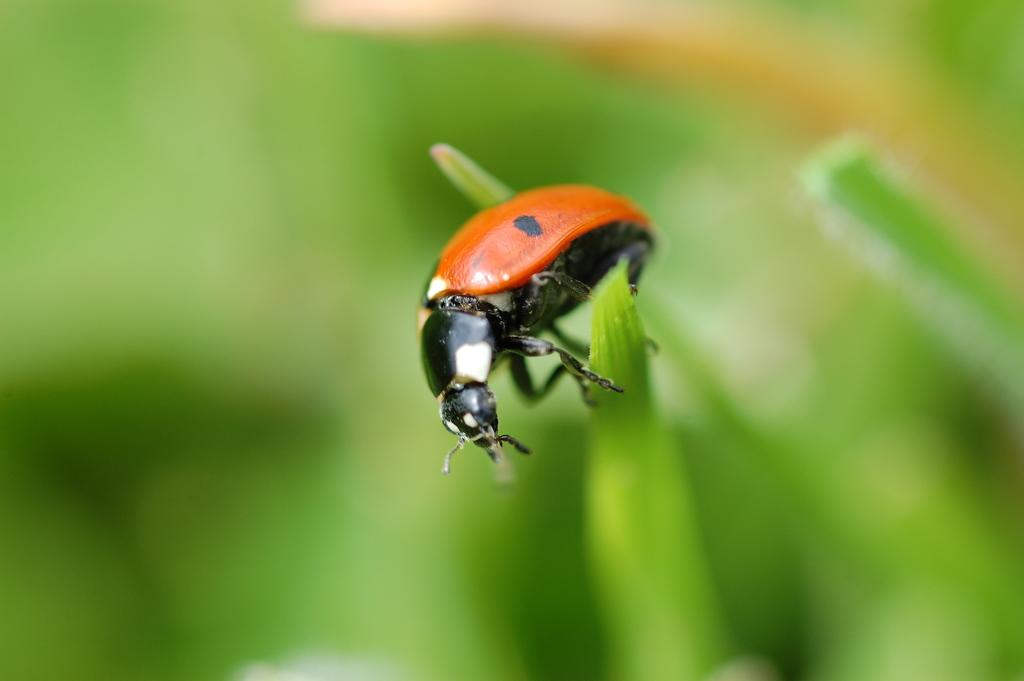What is present in the image? There is a bug in the image. Where is the bug located? The bug is on a leaf. Can you describe the position of the bug and leaf in the image? The bug and leaf are in the center of the image. What type of sheet is covering the bug in the image? There is no sheet present in the image; the bug is on a leaf. Can you tell me how many frogs are visible in the image? There are no frogs present in the image; it only features a bug on a leaf. 